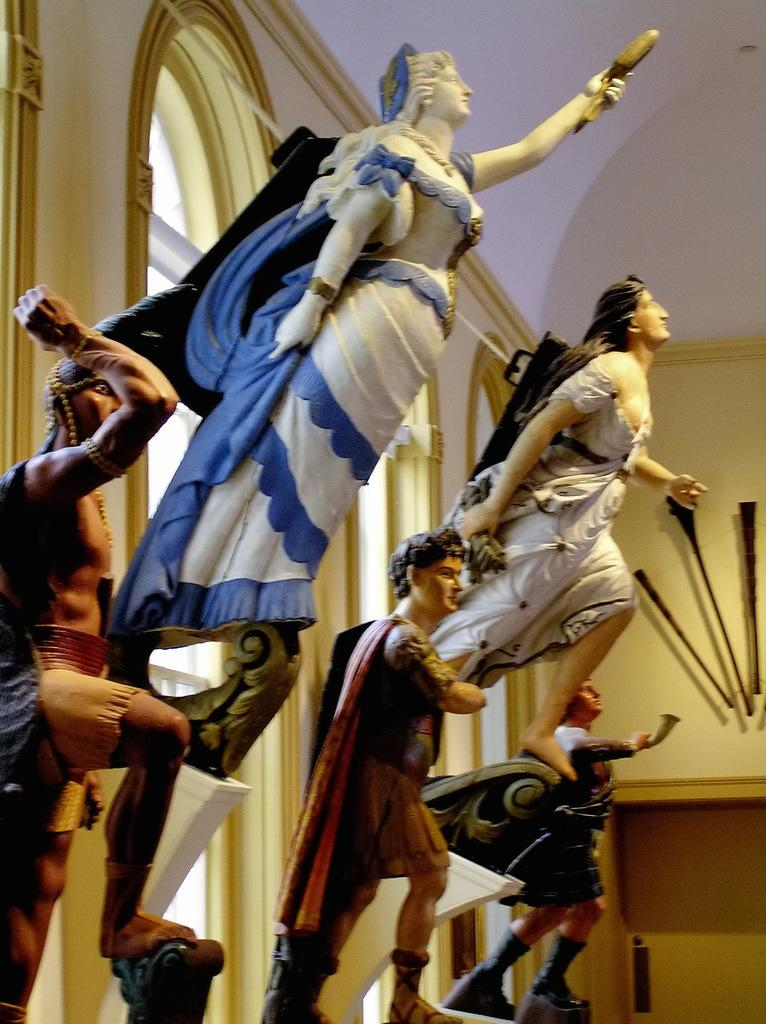What is depicted on the wall in the image? There are idols on the wall in the image. What can be seen at the top of the image? The top of the image includes a roof. How many chairs are visible in the image? There are no chairs present in the image. What wish is granted by the idols in the image? The image does not indicate any specific wishes granted by the idols. 